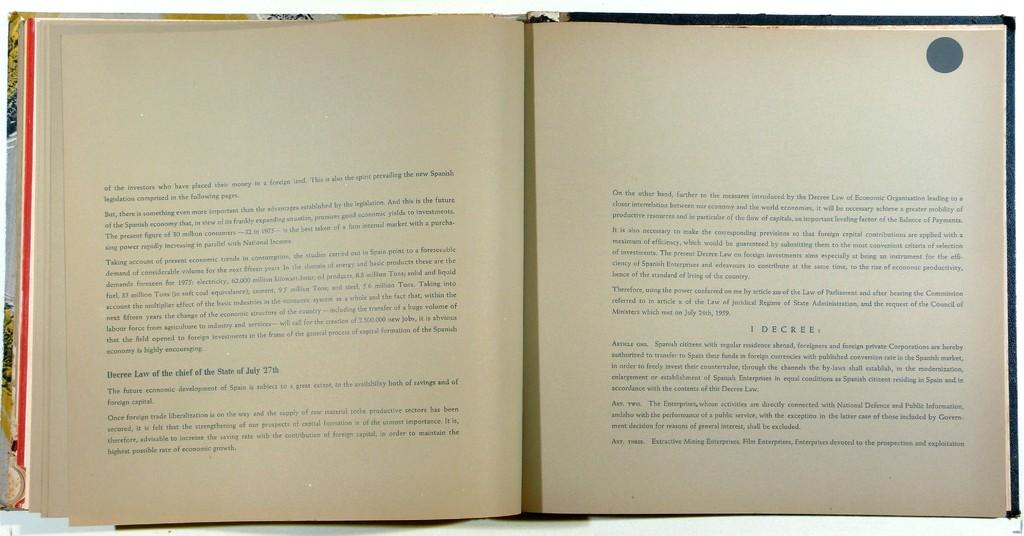<image>
Relay a brief, clear account of the picture shown. An open book that begins talking about the investors. 